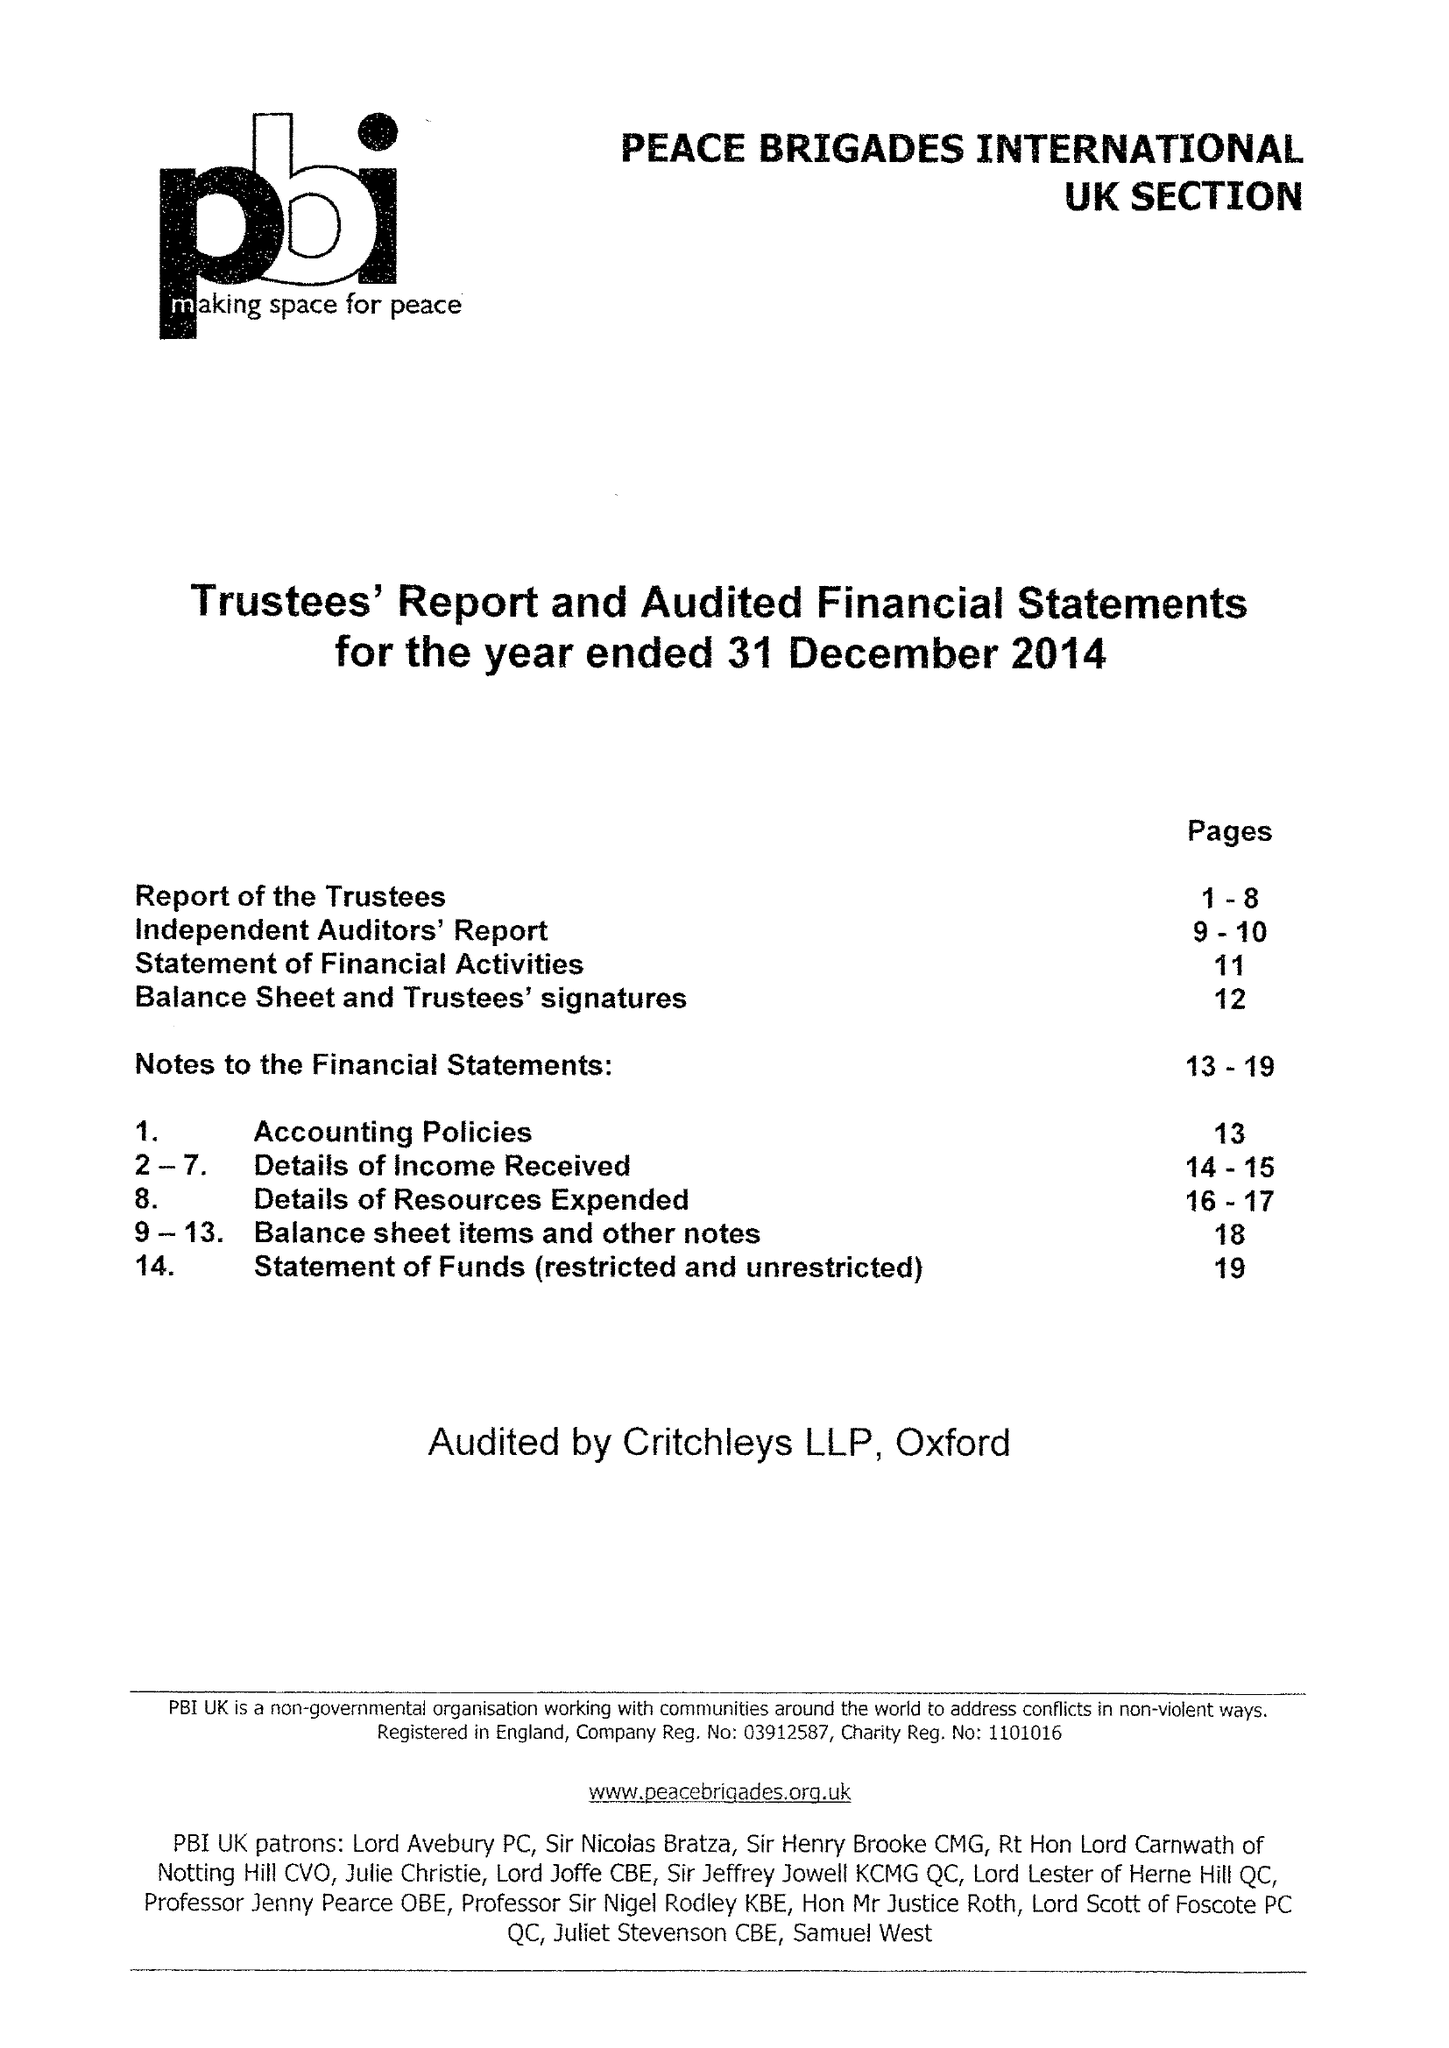What is the value for the charity_number?
Answer the question using a single word or phrase. 1101016 